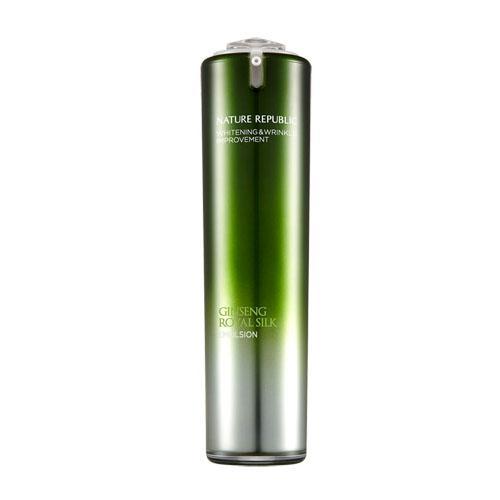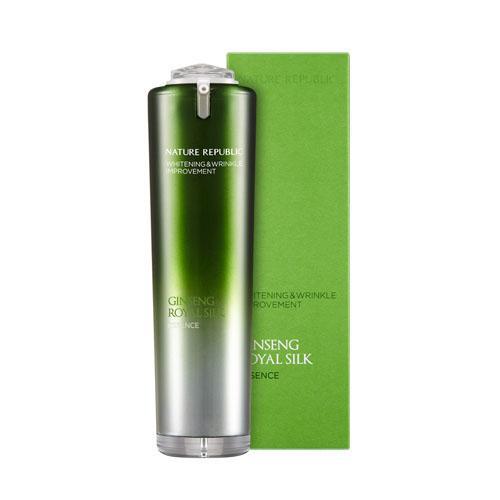The first image is the image on the left, the second image is the image on the right. Considering the images on both sides, is "The container in one of the images has a dark colored cap." valid? Answer yes or no. No. The first image is the image on the left, the second image is the image on the right. For the images shown, is this caption "The combined images include cylindrical bottles with green tops fading down to silver, upright green rectangular boxes, and no other products." true? Answer yes or no. Yes. 